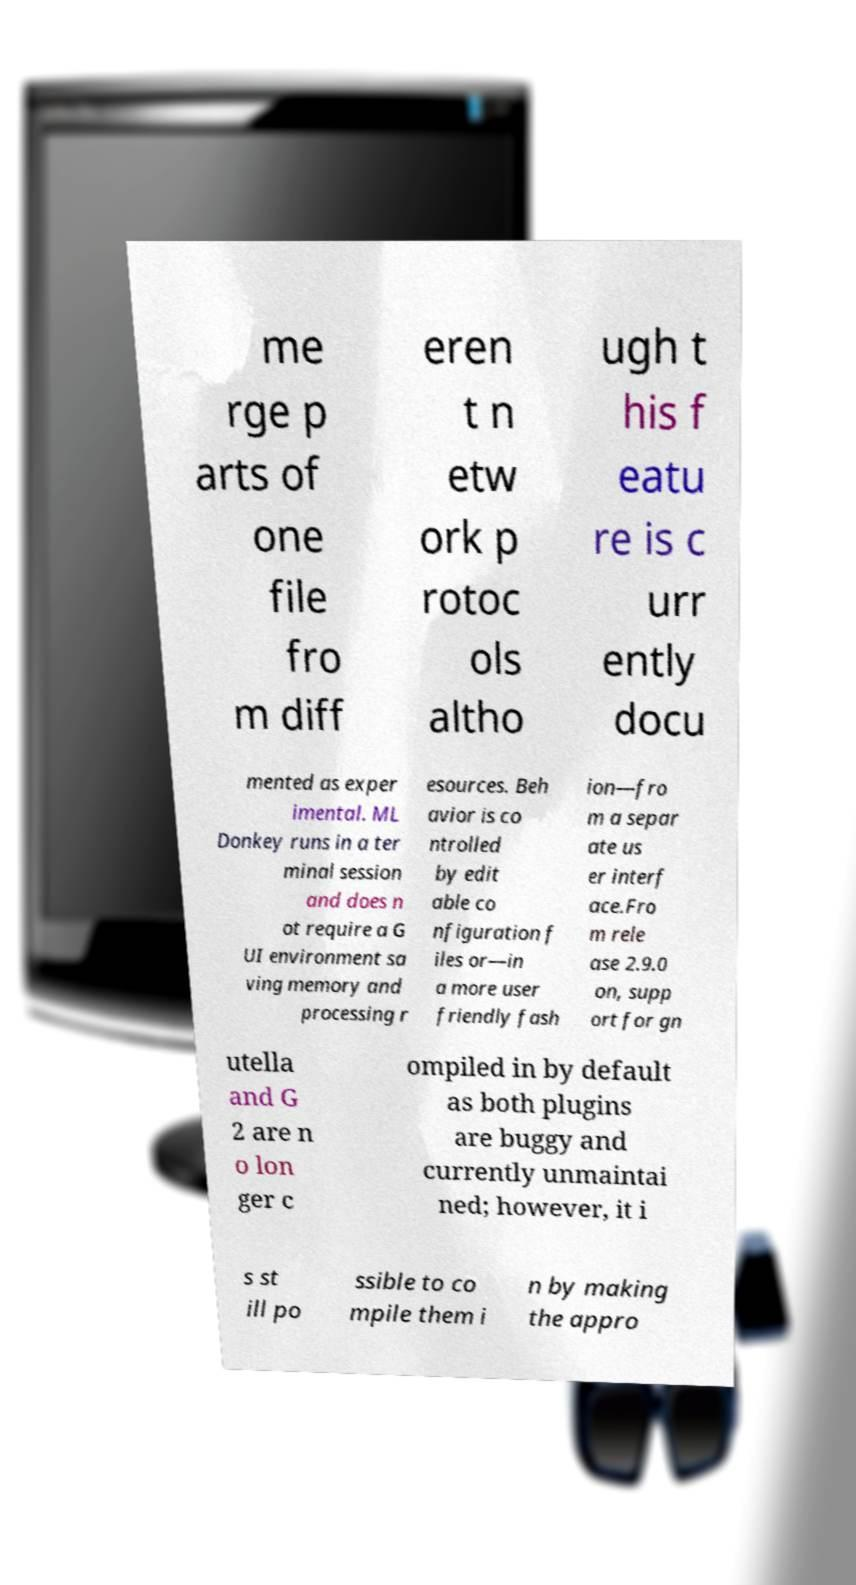Can you accurately transcribe the text from the provided image for me? me rge p arts of one file fro m diff eren t n etw ork p rotoc ols altho ugh t his f eatu re is c urr ently docu mented as exper imental. ML Donkey runs in a ter minal session and does n ot require a G UI environment sa ving memory and processing r esources. Beh avior is co ntrolled by edit able co nfiguration f iles or—in a more user friendly fash ion—fro m a separ ate us er interf ace.Fro m rele ase 2.9.0 on, supp ort for gn utella and G 2 are n o lon ger c ompiled in by default as both plugins are buggy and currently unmaintai ned; however, it i s st ill po ssible to co mpile them i n by making the appro 